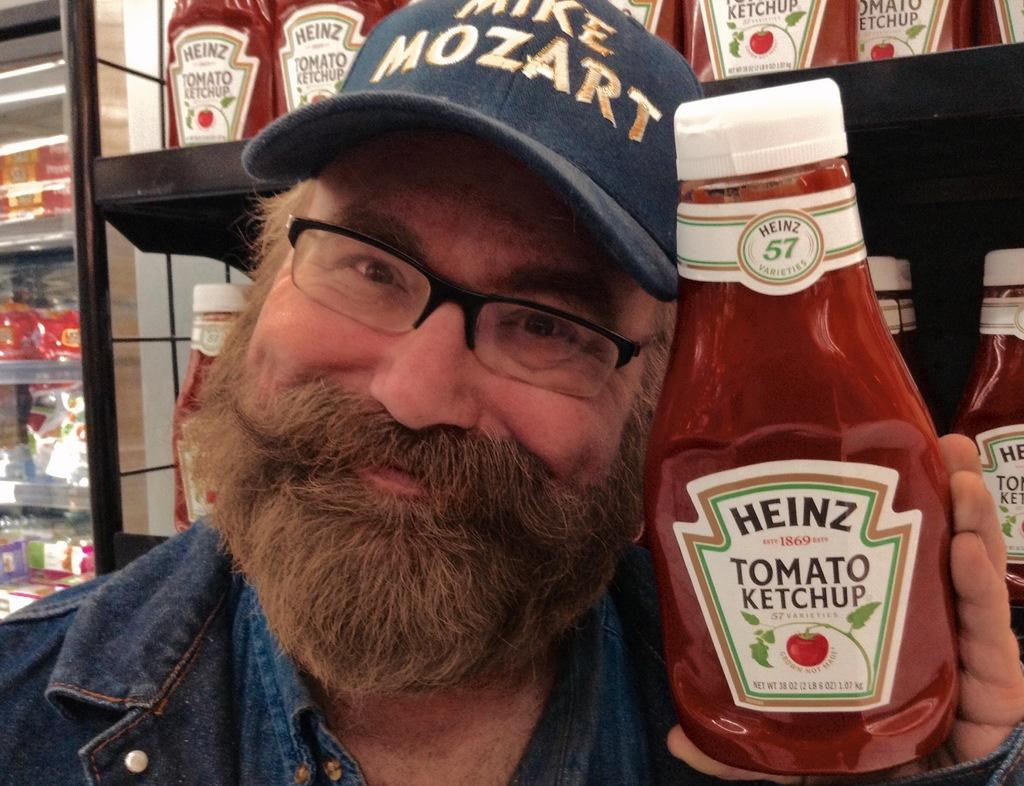What can be seen in the image? There is a person in the image. What is the person wearing? The person is wearing a blue jacket and a cap. What is the person holding in the image? The person is holding a ketchup bottle. What is visible in the background of the image? There is a shelf in the background of the image. What is on the shelf? There are ketchup bottles on the shelf. Can you tell me how many drinks are on the dock in the image? There is no dock or drinks present in the image. What type of tub is visible in the image? There is no tub present in the image. 